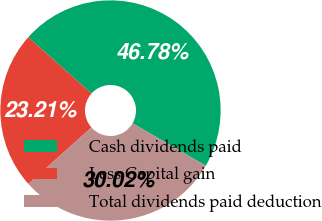Convert chart to OTSL. <chart><loc_0><loc_0><loc_500><loc_500><pie_chart><fcel>Cash dividends paid<fcel>Less Capital gain<fcel>Total dividends paid deduction<nl><fcel>46.78%<fcel>23.21%<fcel>30.02%<nl></chart> 